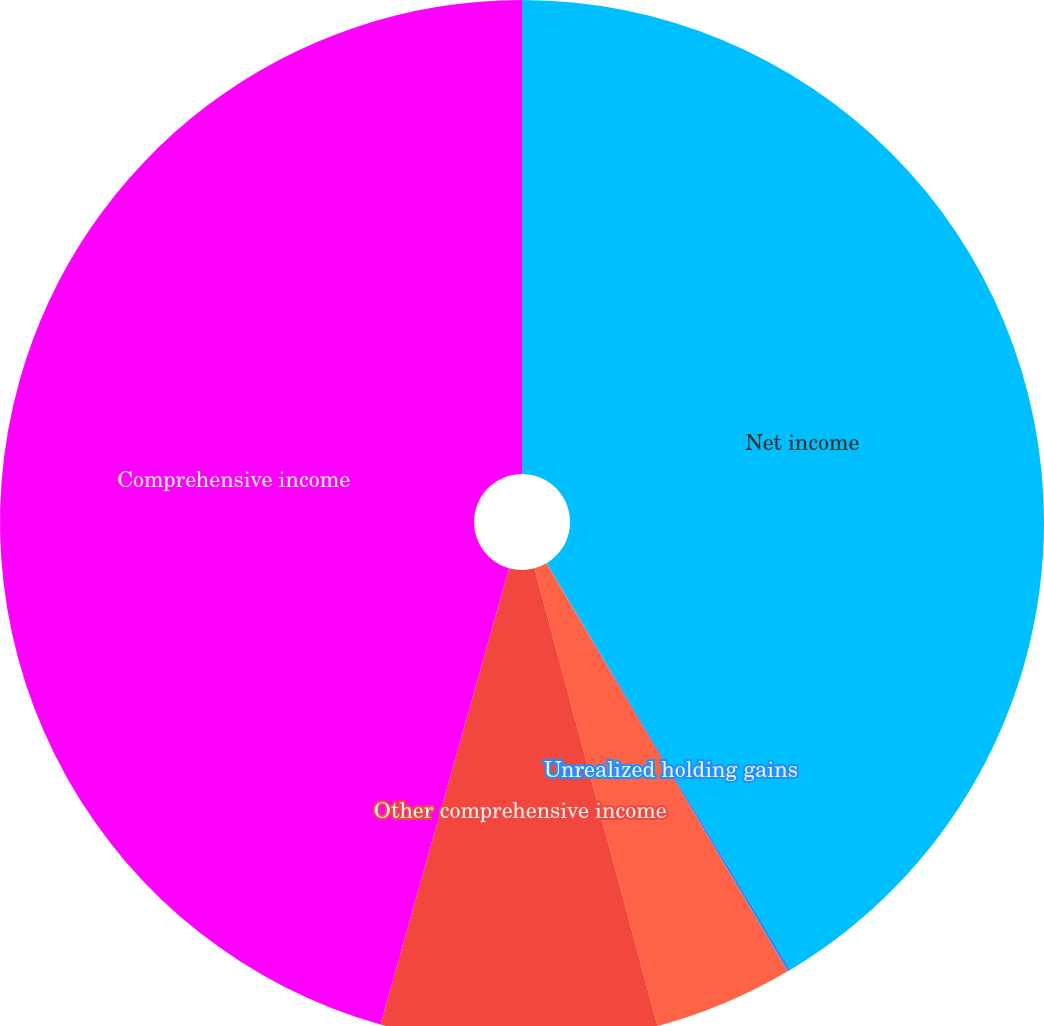<chart> <loc_0><loc_0><loc_500><loc_500><pie_chart><fcel>Net income<fcel>Unrealized holding gains<fcel>Losses reclassified into<fcel>Other comprehensive income<fcel>Comprehensive income<nl><fcel>41.4%<fcel>0.1%<fcel>4.32%<fcel>8.55%<fcel>45.63%<nl></chart> 